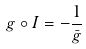Convert formula to latex. <formula><loc_0><loc_0><loc_500><loc_500>g \circ I = - \frac { 1 } { \bar { g } }</formula> 